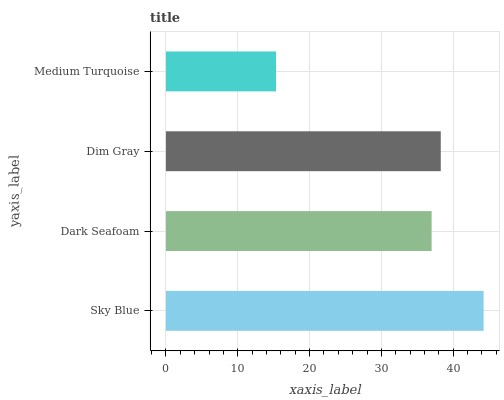Is Medium Turquoise the minimum?
Answer yes or no. Yes. Is Sky Blue the maximum?
Answer yes or no. Yes. Is Dark Seafoam the minimum?
Answer yes or no. No. Is Dark Seafoam the maximum?
Answer yes or no. No. Is Sky Blue greater than Dark Seafoam?
Answer yes or no. Yes. Is Dark Seafoam less than Sky Blue?
Answer yes or no. Yes. Is Dark Seafoam greater than Sky Blue?
Answer yes or no. No. Is Sky Blue less than Dark Seafoam?
Answer yes or no. No. Is Dim Gray the high median?
Answer yes or no. Yes. Is Dark Seafoam the low median?
Answer yes or no. Yes. Is Dark Seafoam the high median?
Answer yes or no. No. Is Sky Blue the low median?
Answer yes or no. No. 